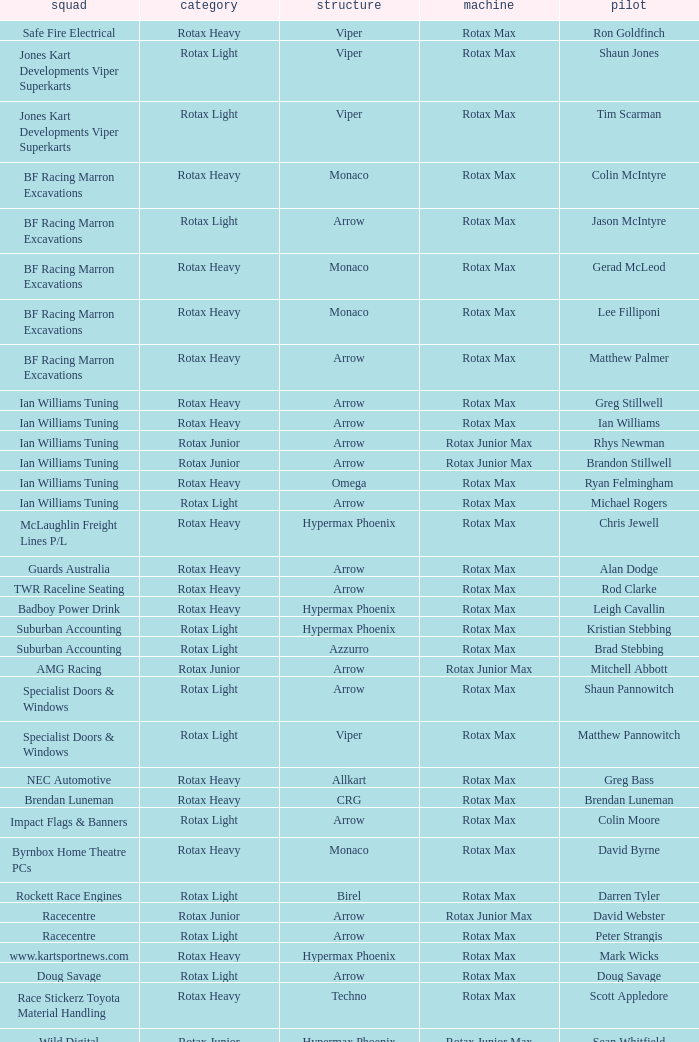What is the name of the team whose class is Rotax Light? Jones Kart Developments Viper Superkarts, Jones Kart Developments Viper Superkarts, BF Racing Marron Excavations, Ian Williams Tuning, Suburban Accounting, Suburban Accounting, Specialist Doors & Windows, Specialist Doors & Windows, Impact Flags & Banners, Rockett Race Engines, Racecentre, Doug Savage. 